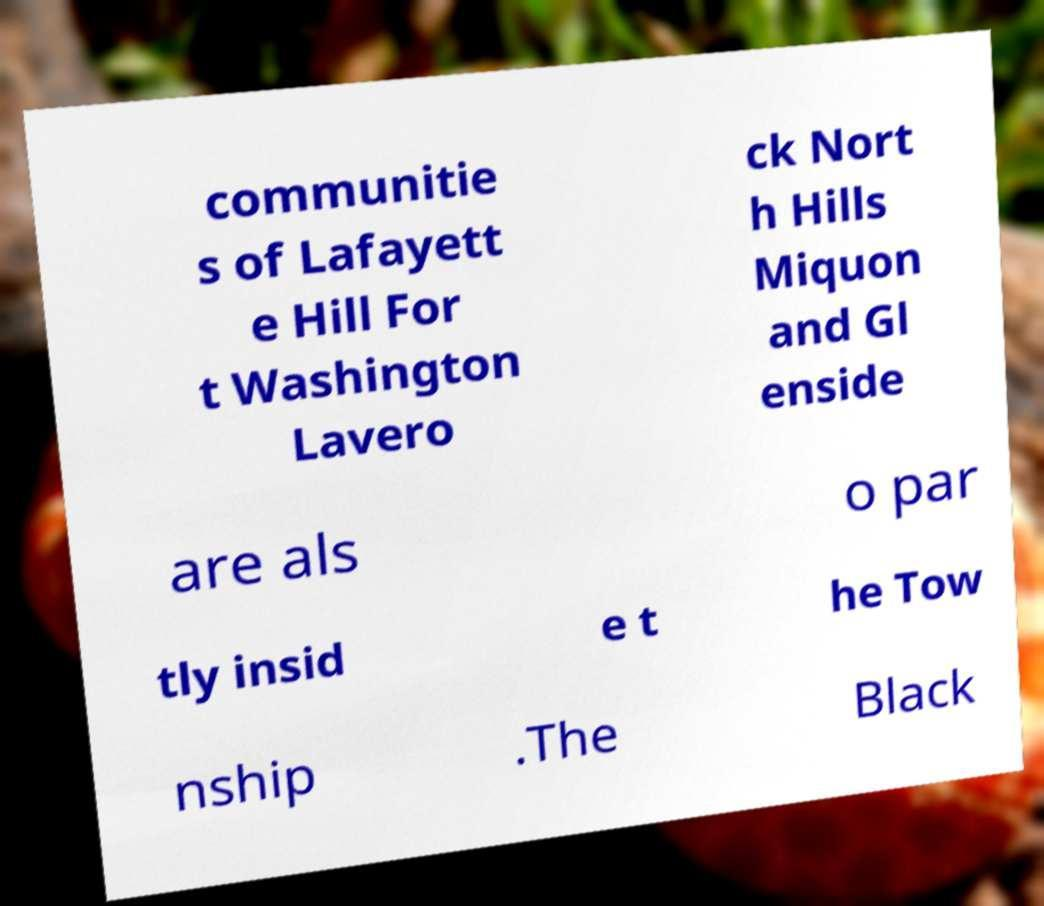Please read and relay the text visible in this image. What does it say? communitie s of Lafayett e Hill For t Washington Lavero ck Nort h Hills Miquon and Gl enside are als o par tly insid e t he Tow nship .The Black 